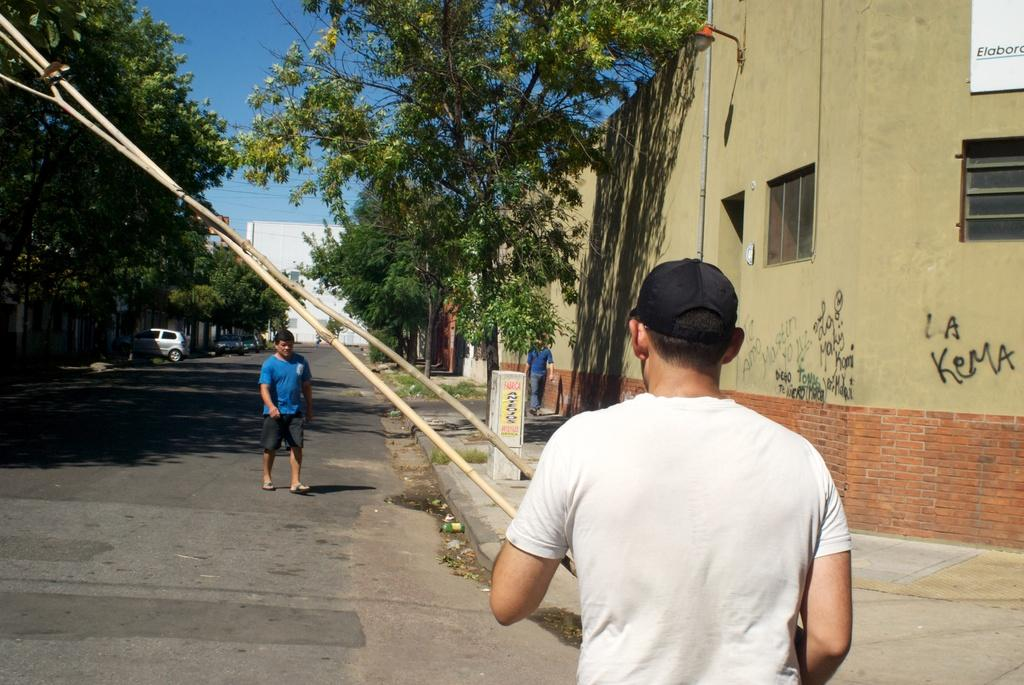What type of structures can be seen in the image? There are buildings in the image. What feature do the buildings have? The buildings have glass windows. What else can be seen in the image besides buildings? There are trees, vehicles on the road, and people walking in the image. What is the color of the sky in the image? The sky is blue in color. What type of pin can be seen holding the nation's flag in the image? There is no pin or flag present in the image. What type of wool is being used to make the clothing of the people walking in the image? There is no information about the clothing or materials used in the image. 